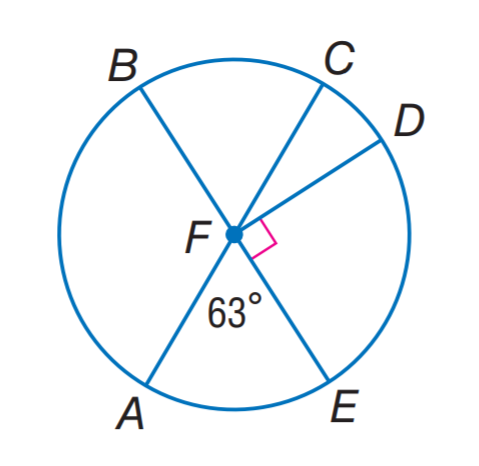Question: In \odot F, find m \widehat A D B.
Choices:
A. 63
B. 153
C. 233
D. 243
Answer with the letter. Answer: D Question: In \odot F, find m \widehat A E D.
Choices:
A. 63
B. 93
C. 123
D. 153
Answer with the letter. Answer: D 